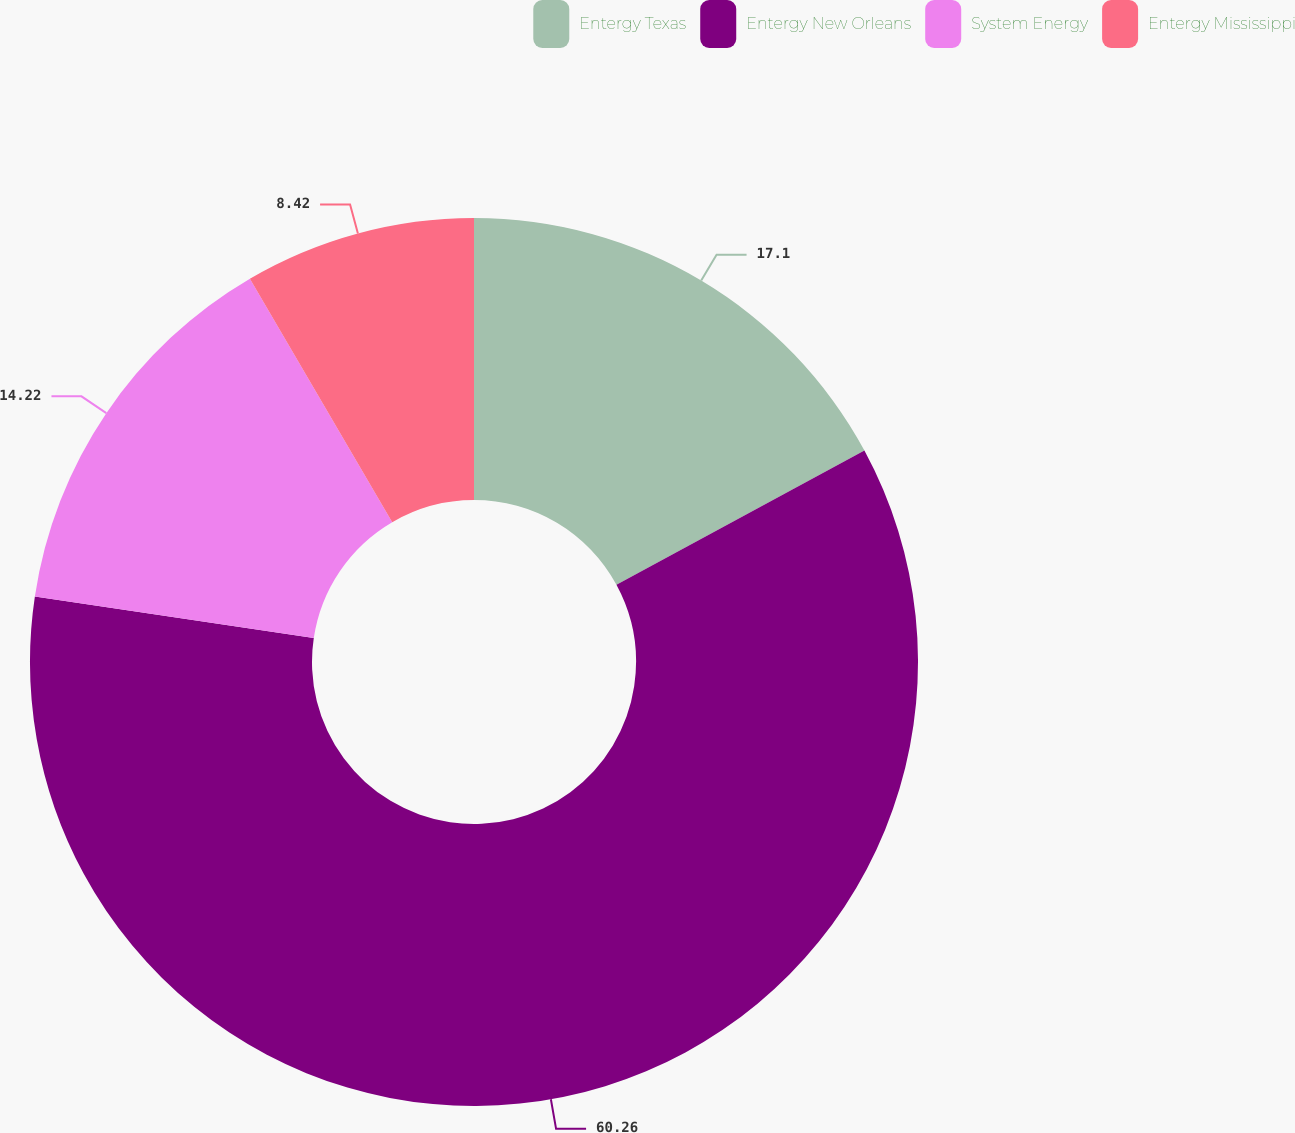Convert chart to OTSL. <chart><loc_0><loc_0><loc_500><loc_500><pie_chart><fcel>Entergy Texas<fcel>Entergy New Orleans<fcel>System Energy<fcel>Entergy Mississippi<nl><fcel>17.1%<fcel>60.26%<fcel>14.22%<fcel>8.42%<nl></chart> 